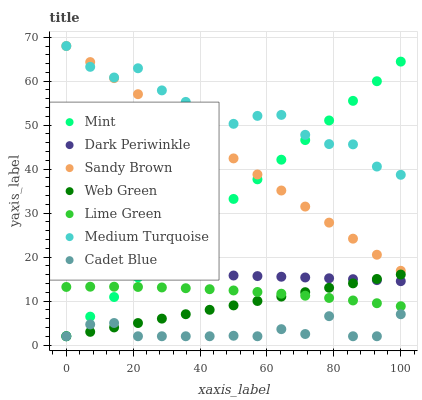Does Cadet Blue have the minimum area under the curve?
Answer yes or no. Yes. Does Medium Turquoise have the maximum area under the curve?
Answer yes or no. Yes. Does Sandy Brown have the minimum area under the curve?
Answer yes or no. No. Does Sandy Brown have the maximum area under the curve?
Answer yes or no. No. Is Web Green the smoothest?
Answer yes or no. Yes. Is Medium Turquoise the roughest?
Answer yes or no. Yes. Is Sandy Brown the smoothest?
Answer yes or no. No. Is Sandy Brown the roughest?
Answer yes or no. No. Does Cadet Blue have the lowest value?
Answer yes or no. Yes. Does Sandy Brown have the lowest value?
Answer yes or no. No. Does Medium Turquoise have the highest value?
Answer yes or no. Yes. Does Web Green have the highest value?
Answer yes or no. No. Is Cadet Blue less than Lime Green?
Answer yes or no. Yes. Is Lime Green greater than Cadet Blue?
Answer yes or no. Yes. Does Lime Green intersect Mint?
Answer yes or no. Yes. Is Lime Green less than Mint?
Answer yes or no. No. Is Lime Green greater than Mint?
Answer yes or no. No. Does Cadet Blue intersect Lime Green?
Answer yes or no. No. 